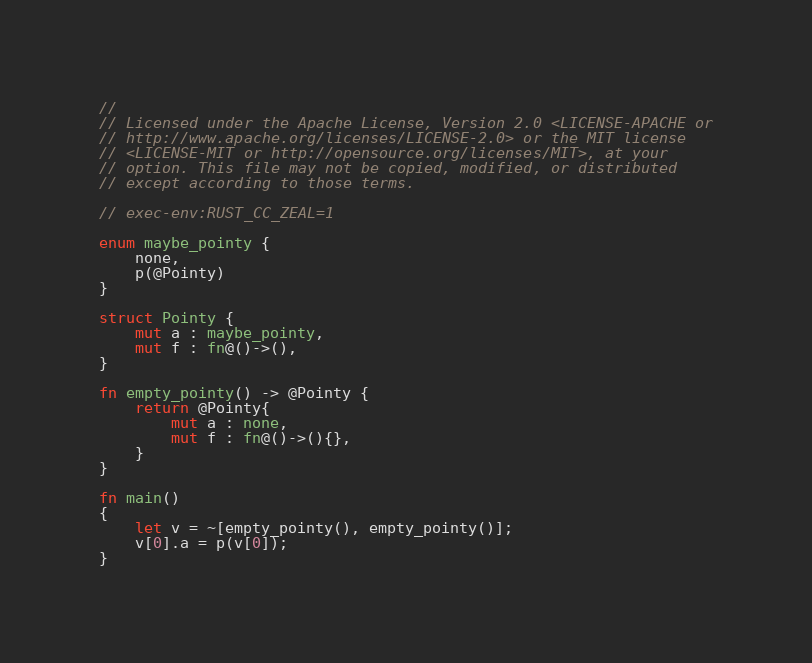Convert code to text. <code><loc_0><loc_0><loc_500><loc_500><_Rust_>//
// Licensed under the Apache License, Version 2.0 <LICENSE-APACHE or
// http://www.apache.org/licenses/LICENSE-2.0> or the MIT license
// <LICENSE-MIT or http://opensource.org/licenses/MIT>, at your
// option. This file may not be copied, modified, or distributed
// except according to those terms.

// exec-env:RUST_CC_ZEAL=1

enum maybe_pointy {
    none,
    p(@Pointy)
}

struct Pointy {
    mut a : maybe_pointy,
    mut f : fn@()->(),
}

fn empty_pointy() -> @Pointy {
    return @Pointy{
        mut a : none,
        mut f : fn@()->(){},
    }
}

fn main()
{
    let v = ~[empty_pointy(), empty_pointy()];
    v[0].a = p(v[0]);
}
</code> 